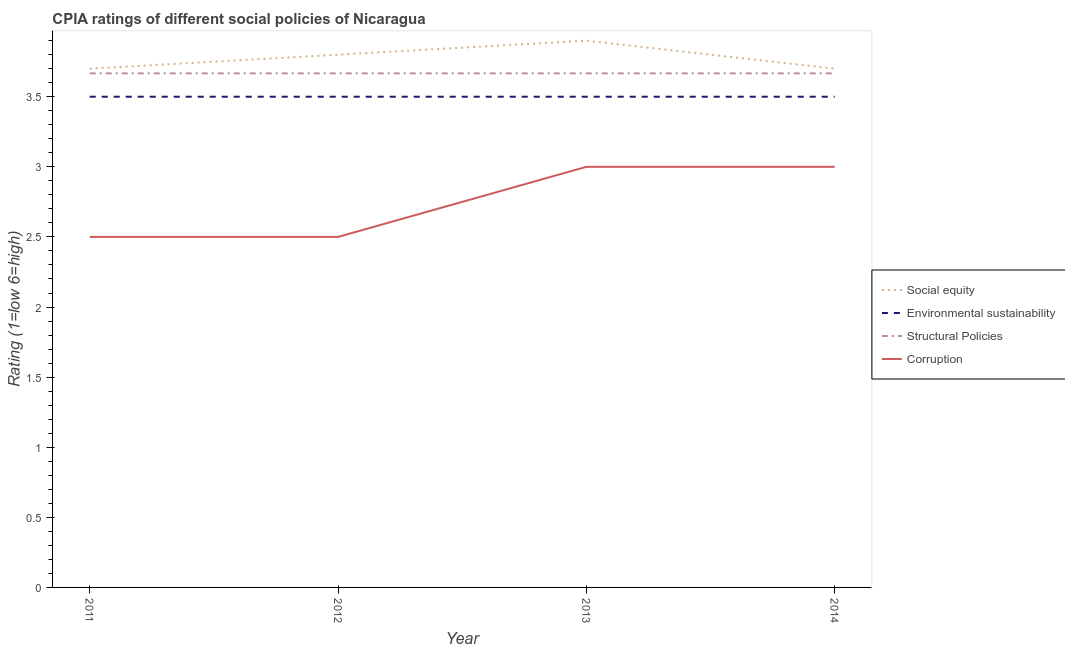How many different coloured lines are there?
Keep it short and to the point. 4. What is the cpia rating of social equity in 2013?
Your answer should be compact. 3.9. Across all years, what is the maximum cpia rating of environmental sustainability?
Offer a terse response. 3.5. In which year was the cpia rating of structural policies maximum?
Provide a succinct answer. 2014. In which year was the cpia rating of social equity minimum?
Keep it short and to the point. 2011. What is the total cpia rating of environmental sustainability in the graph?
Give a very brief answer. 14. What is the difference between the cpia rating of social equity in 2013 and that in 2014?
Offer a very short reply. 0.2. What is the difference between the cpia rating of social equity in 2014 and the cpia rating of corruption in 2013?
Provide a short and direct response. 0.7. What is the average cpia rating of corruption per year?
Your response must be concise. 2.75. In the year 2013, what is the difference between the cpia rating of structural policies and cpia rating of corruption?
Your answer should be very brief. 0.67. In how many years, is the cpia rating of environmental sustainability greater than 0.5?
Keep it short and to the point. 4. What is the ratio of the cpia rating of corruption in 2012 to that in 2013?
Give a very brief answer. 0.83. Is the difference between the cpia rating of structural policies in 2013 and 2014 greater than the difference between the cpia rating of corruption in 2013 and 2014?
Provide a short and direct response. No. What is the difference between the highest and the lowest cpia rating of social equity?
Give a very brief answer. 0.2. In how many years, is the cpia rating of corruption greater than the average cpia rating of corruption taken over all years?
Offer a terse response. 2. Is it the case that in every year, the sum of the cpia rating of corruption and cpia rating of structural policies is greater than the sum of cpia rating of social equity and cpia rating of environmental sustainability?
Provide a succinct answer. Yes. Is it the case that in every year, the sum of the cpia rating of social equity and cpia rating of environmental sustainability is greater than the cpia rating of structural policies?
Provide a short and direct response. Yes. Is the cpia rating of structural policies strictly less than the cpia rating of environmental sustainability over the years?
Offer a very short reply. No. How many lines are there?
Provide a succinct answer. 4. Are the values on the major ticks of Y-axis written in scientific E-notation?
Your answer should be compact. No. Does the graph contain any zero values?
Your response must be concise. No. How are the legend labels stacked?
Ensure brevity in your answer.  Vertical. What is the title of the graph?
Keep it short and to the point. CPIA ratings of different social policies of Nicaragua. What is the label or title of the Y-axis?
Make the answer very short. Rating (1=low 6=high). What is the Rating (1=low 6=high) in Structural Policies in 2011?
Ensure brevity in your answer.  3.67. What is the Rating (1=low 6=high) in Corruption in 2011?
Your answer should be compact. 2.5. What is the Rating (1=low 6=high) of Environmental sustainability in 2012?
Offer a very short reply. 3.5. What is the Rating (1=low 6=high) of Structural Policies in 2012?
Offer a very short reply. 3.67. What is the Rating (1=low 6=high) of Corruption in 2012?
Your answer should be very brief. 2.5. What is the Rating (1=low 6=high) in Social equity in 2013?
Ensure brevity in your answer.  3.9. What is the Rating (1=low 6=high) in Environmental sustainability in 2013?
Your response must be concise. 3.5. What is the Rating (1=low 6=high) of Structural Policies in 2013?
Your response must be concise. 3.67. What is the Rating (1=low 6=high) of Structural Policies in 2014?
Offer a terse response. 3.67. Across all years, what is the maximum Rating (1=low 6=high) in Environmental sustainability?
Your answer should be very brief. 3.5. Across all years, what is the maximum Rating (1=low 6=high) in Structural Policies?
Offer a very short reply. 3.67. Across all years, what is the maximum Rating (1=low 6=high) in Corruption?
Offer a very short reply. 3. Across all years, what is the minimum Rating (1=low 6=high) in Structural Policies?
Your answer should be compact. 3.67. Across all years, what is the minimum Rating (1=low 6=high) in Corruption?
Your answer should be very brief. 2.5. What is the total Rating (1=low 6=high) of Environmental sustainability in the graph?
Your answer should be compact. 14. What is the total Rating (1=low 6=high) of Structural Policies in the graph?
Offer a terse response. 14.67. What is the difference between the Rating (1=low 6=high) in Social equity in 2011 and that in 2012?
Your answer should be very brief. -0.1. What is the difference between the Rating (1=low 6=high) of Structural Policies in 2011 and that in 2012?
Provide a succinct answer. 0. What is the difference between the Rating (1=low 6=high) of Environmental sustainability in 2011 and that in 2013?
Provide a short and direct response. 0. What is the difference between the Rating (1=low 6=high) of Corruption in 2011 and that in 2013?
Your answer should be very brief. -0.5. What is the difference between the Rating (1=low 6=high) in Environmental sustainability in 2011 and that in 2014?
Give a very brief answer. 0. What is the difference between the Rating (1=low 6=high) in Structural Policies in 2011 and that in 2014?
Give a very brief answer. -0. What is the difference between the Rating (1=low 6=high) of Social equity in 2012 and that in 2013?
Your response must be concise. -0.1. What is the difference between the Rating (1=low 6=high) of Corruption in 2012 and that in 2013?
Offer a terse response. -0.5. What is the difference between the Rating (1=low 6=high) of Social equity in 2012 and that in 2014?
Provide a short and direct response. 0.1. What is the difference between the Rating (1=low 6=high) in Environmental sustainability in 2012 and that in 2014?
Provide a short and direct response. 0. What is the difference between the Rating (1=low 6=high) in Structural Policies in 2012 and that in 2014?
Your answer should be compact. -0. What is the difference between the Rating (1=low 6=high) in Social equity in 2013 and that in 2014?
Provide a short and direct response. 0.2. What is the difference between the Rating (1=low 6=high) in Social equity in 2011 and the Rating (1=low 6=high) in Environmental sustainability in 2012?
Ensure brevity in your answer.  0.2. What is the difference between the Rating (1=low 6=high) in Environmental sustainability in 2011 and the Rating (1=low 6=high) in Structural Policies in 2012?
Provide a succinct answer. -0.17. What is the difference between the Rating (1=low 6=high) of Structural Policies in 2011 and the Rating (1=low 6=high) of Corruption in 2012?
Your answer should be compact. 1.17. What is the difference between the Rating (1=low 6=high) of Social equity in 2011 and the Rating (1=low 6=high) of Environmental sustainability in 2013?
Your answer should be very brief. 0.2. What is the difference between the Rating (1=low 6=high) of Social equity in 2011 and the Rating (1=low 6=high) of Structural Policies in 2013?
Your answer should be compact. 0.03. What is the difference between the Rating (1=low 6=high) of Environmental sustainability in 2011 and the Rating (1=low 6=high) of Structural Policies in 2013?
Your response must be concise. -0.17. What is the difference between the Rating (1=low 6=high) of Environmental sustainability in 2011 and the Rating (1=low 6=high) of Corruption in 2013?
Your response must be concise. 0.5. What is the difference between the Rating (1=low 6=high) of Social equity in 2011 and the Rating (1=low 6=high) of Environmental sustainability in 2014?
Give a very brief answer. 0.2. What is the difference between the Rating (1=low 6=high) in Social equity in 2011 and the Rating (1=low 6=high) in Corruption in 2014?
Provide a short and direct response. 0.7. What is the difference between the Rating (1=low 6=high) of Structural Policies in 2011 and the Rating (1=low 6=high) of Corruption in 2014?
Offer a terse response. 0.67. What is the difference between the Rating (1=low 6=high) of Social equity in 2012 and the Rating (1=low 6=high) of Environmental sustainability in 2013?
Ensure brevity in your answer.  0.3. What is the difference between the Rating (1=low 6=high) of Social equity in 2012 and the Rating (1=low 6=high) of Structural Policies in 2013?
Provide a succinct answer. 0.13. What is the difference between the Rating (1=low 6=high) in Environmental sustainability in 2012 and the Rating (1=low 6=high) in Structural Policies in 2013?
Provide a short and direct response. -0.17. What is the difference between the Rating (1=low 6=high) in Structural Policies in 2012 and the Rating (1=low 6=high) in Corruption in 2013?
Offer a terse response. 0.67. What is the difference between the Rating (1=low 6=high) of Social equity in 2012 and the Rating (1=low 6=high) of Structural Policies in 2014?
Provide a succinct answer. 0.13. What is the difference between the Rating (1=low 6=high) in Environmental sustainability in 2012 and the Rating (1=low 6=high) in Corruption in 2014?
Ensure brevity in your answer.  0.5. What is the difference between the Rating (1=low 6=high) of Structural Policies in 2012 and the Rating (1=low 6=high) of Corruption in 2014?
Ensure brevity in your answer.  0.67. What is the difference between the Rating (1=low 6=high) in Social equity in 2013 and the Rating (1=low 6=high) in Environmental sustainability in 2014?
Your response must be concise. 0.4. What is the difference between the Rating (1=low 6=high) in Social equity in 2013 and the Rating (1=low 6=high) in Structural Policies in 2014?
Your response must be concise. 0.23. What is the difference between the Rating (1=low 6=high) of Structural Policies in 2013 and the Rating (1=low 6=high) of Corruption in 2014?
Your answer should be very brief. 0.67. What is the average Rating (1=low 6=high) in Social equity per year?
Offer a terse response. 3.77. What is the average Rating (1=low 6=high) of Structural Policies per year?
Offer a terse response. 3.67. What is the average Rating (1=low 6=high) in Corruption per year?
Your response must be concise. 2.75. In the year 2011, what is the difference between the Rating (1=low 6=high) in Social equity and Rating (1=low 6=high) in Environmental sustainability?
Provide a short and direct response. 0.2. In the year 2011, what is the difference between the Rating (1=low 6=high) of Social equity and Rating (1=low 6=high) of Structural Policies?
Ensure brevity in your answer.  0.03. In the year 2011, what is the difference between the Rating (1=low 6=high) of Social equity and Rating (1=low 6=high) of Corruption?
Offer a terse response. 1.2. In the year 2011, what is the difference between the Rating (1=low 6=high) in Structural Policies and Rating (1=low 6=high) in Corruption?
Offer a very short reply. 1.17. In the year 2012, what is the difference between the Rating (1=low 6=high) in Social equity and Rating (1=low 6=high) in Structural Policies?
Your answer should be compact. 0.13. In the year 2012, what is the difference between the Rating (1=low 6=high) of Structural Policies and Rating (1=low 6=high) of Corruption?
Provide a short and direct response. 1.17. In the year 2013, what is the difference between the Rating (1=low 6=high) in Social equity and Rating (1=low 6=high) in Structural Policies?
Your response must be concise. 0.23. In the year 2013, what is the difference between the Rating (1=low 6=high) of Social equity and Rating (1=low 6=high) of Corruption?
Your answer should be compact. 0.9. In the year 2013, what is the difference between the Rating (1=low 6=high) of Environmental sustainability and Rating (1=low 6=high) of Corruption?
Give a very brief answer. 0.5. In the year 2013, what is the difference between the Rating (1=low 6=high) of Structural Policies and Rating (1=low 6=high) of Corruption?
Your answer should be compact. 0.67. In the year 2014, what is the difference between the Rating (1=low 6=high) of Social equity and Rating (1=low 6=high) of Corruption?
Keep it short and to the point. 0.7. In the year 2014, what is the difference between the Rating (1=low 6=high) of Environmental sustainability and Rating (1=low 6=high) of Corruption?
Your response must be concise. 0.5. What is the ratio of the Rating (1=low 6=high) in Social equity in 2011 to that in 2012?
Your answer should be very brief. 0.97. What is the ratio of the Rating (1=low 6=high) of Corruption in 2011 to that in 2012?
Your response must be concise. 1. What is the ratio of the Rating (1=low 6=high) of Social equity in 2011 to that in 2013?
Your answer should be compact. 0.95. What is the ratio of the Rating (1=low 6=high) of Environmental sustainability in 2011 to that in 2013?
Your answer should be compact. 1. What is the ratio of the Rating (1=low 6=high) of Structural Policies in 2011 to that in 2013?
Your answer should be compact. 1. What is the ratio of the Rating (1=low 6=high) in Corruption in 2011 to that in 2013?
Offer a terse response. 0.83. What is the ratio of the Rating (1=low 6=high) of Social equity in 2011 to that in 2014?
Offer a very short reply. 1. What is the ratio of the Rating (1=low 6=high) of Structural Policies in 2011 to that in 2014?
Your answer should be compact. 1. What is the ratio of the Rating (1=low 6=high) of Corruption in 2011 to that in 2014?
Provide a short and direct response. 0.83. What is the ratio of the Rating (1=low 6=high) in Social equity in 2012 to that in 2013?
Provide a short and direct response. 0.97. What is the ratio of the Rating (1=low 6=high) in Structural Policies in 2012 to that in 2013?
Give a very brief answer. 1. What is the ratio of the Rating (1=low 6=high) in Corruption in 2012 to that in 2013?
Provide a succinct answer. 0.83. What is the ratio of the Rating (1=low 6=high) of Social equity in 2012 to that in 2014?
Keep it short and to the point. 1.03. What is the ratio of the Rating (1=low 6=high) of Environmental sustainability in 2012 to that in 2014?
Keep it short and to the point. 1. What is the ratio of the Rating (1=low 6=high) of Corruption in 2012 to that in 2014?
Keep it short and to the point. 0.83. What is the ratio of the Rating (1=low 6=high) of Social equity in 2013 to that in 2014?
Provide a short and direct response. 1.05. What is the ratio of the Rating (1=low 6=high) of Environmental sustainability in 2013 to that in 2014?
Keep it short and to the point. 1. What is the difference between the highest and the second highest Rating (1=low 6=high) in Social equity?
Your answer should be compact. 0.1. What is the difference between the highest and the second highest Rating (1=low 6=high) in Environmental sustainability?
Make the answer very short. 0. What is the difference between the highest and the second highest Rating (1=low 6=high) of Corruption?
Your answer should be compact. 0. What is the difference between the highest and the lowest Rating (1=low 6=high) in Social equity?
Give a very brief answer. 0.2. What is the difference between the highest and the lowest Rating (1=low 6=high) in Structural Policies?
Give a very brief answer. 0. What is the difference between the highest and the lowest Rating (1=low 6=high) of Corruption?
Provide a short and direct response. 0.5. 